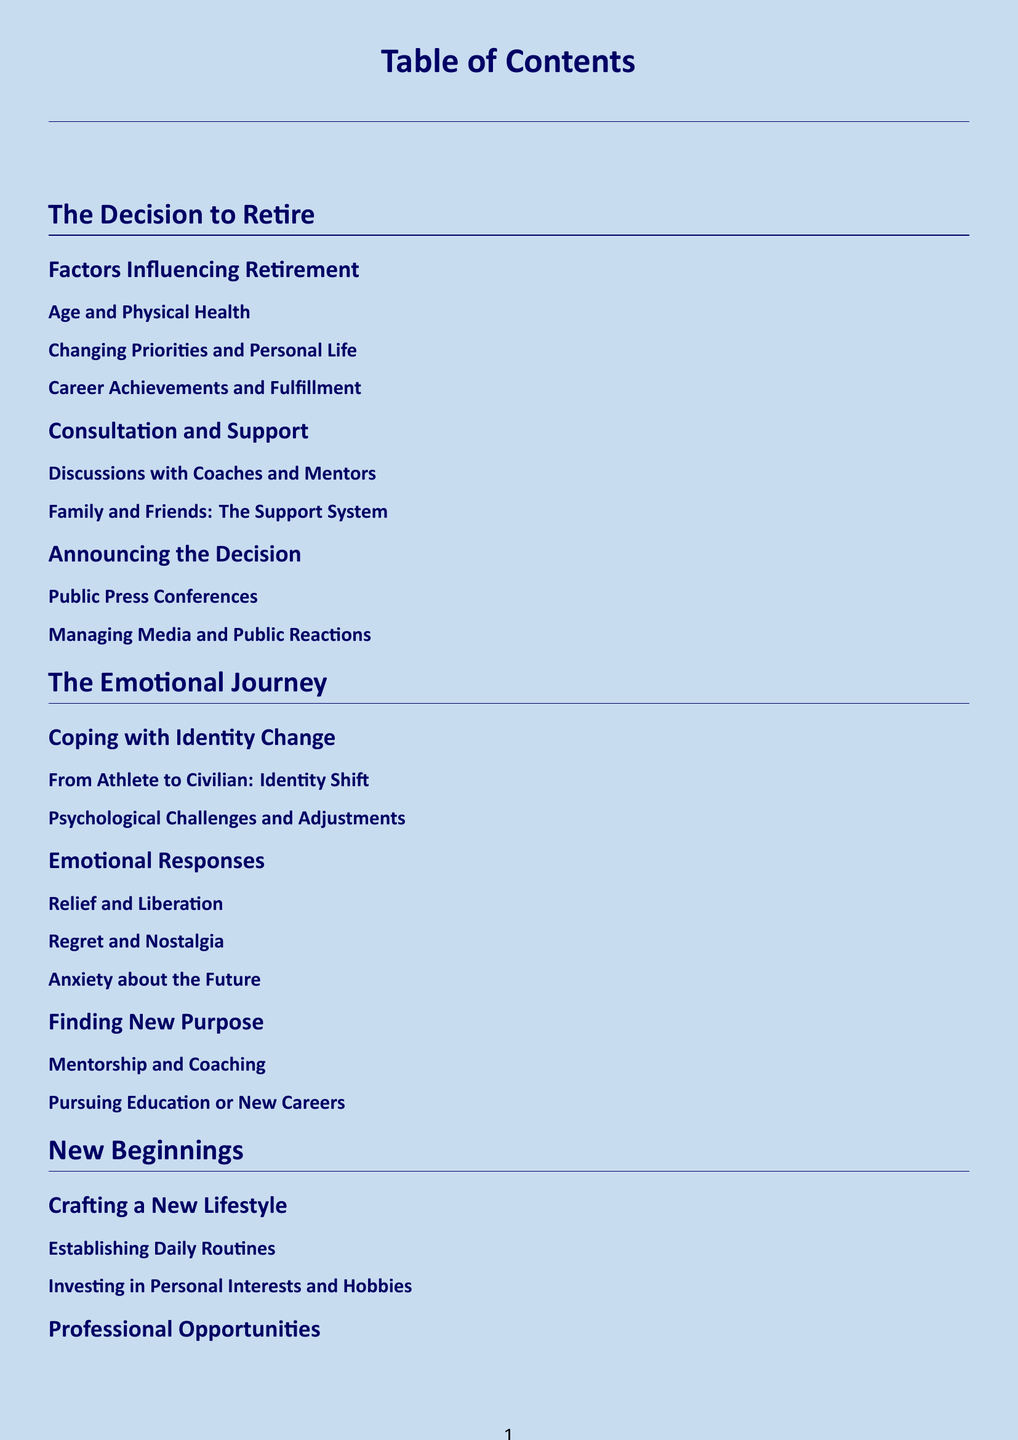What are the main factors influencing retirement? The section outlines the primary influences on retirement decision-making, including age, physical health, and personal priorities.
Answer: Age and Physical Health, Changing Priorities and Personal Life, Career Achievements and Fulfillment Who provides support during the decision to retire? This subsection discusses the importance of consultation with coaches, mentors, and the role of family and friends in providing support.
Answer: Coaches and Mentors, Family and Friends What emotional response is associated with the retirement journey? This section identifies key emotional responses that skaters may experience when transitioning to retirement, focusing on relief, regret, and anxiety.
Answer: Relief and Liberation, Regret and Nostalgia, Anxiety about the Future What new purpose can athletes find after retirement? This subsection elaborates on new roles athletes might pursue after quitting their sport, particularly in mentorship and education.
Answer: Mentorship and Coaching, Pursuing Education or New Careers What is one component of crafting a new lifestyle post-retirement? This subsection discusses strategies for establishing new routines and engaging in personal hobbies as athletes transition out of competition.
Answer: Establishing Daily Routines, Investing in Personal Interests and Hobbies 